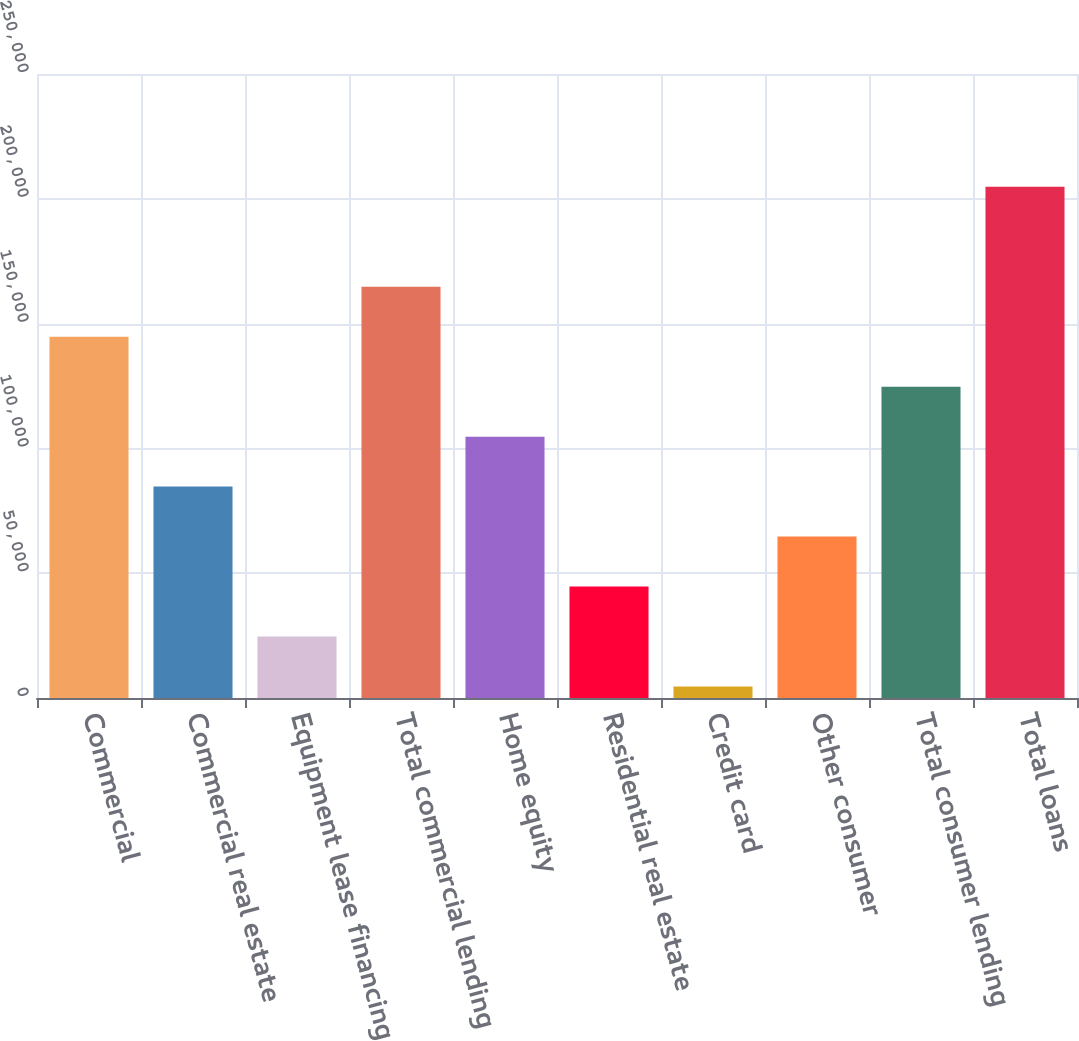Convert chart. <chart><loc_0><loc_0><loc_500><loc_500><bar_chart><fcel>Commercial<fcel>Commercial real estate<fcel>Equipment lease financing<fcel>Total commercial lending<fcel>Home equity<fcel>Residential real estate<fcel>Credit card<fcel>Other consumer<fcel>Total consumer lending<fcel>Total loans<nl><fcel>144756<fcel>84694<fcel>24632.5<fcel>164776<fcel>104714<fcel>44653<fcel>4612<fcel>64673.5<fcel>124735<fcel>204817<nl></chart> 